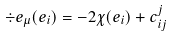<formula> <loc_0><loc_0><loc_500><loc_500>\div e _ { \mu } ( e _ { i } ) = - 2 \chi ( e _ { i } ) + c _ { i j } ^ { j }</formula> 